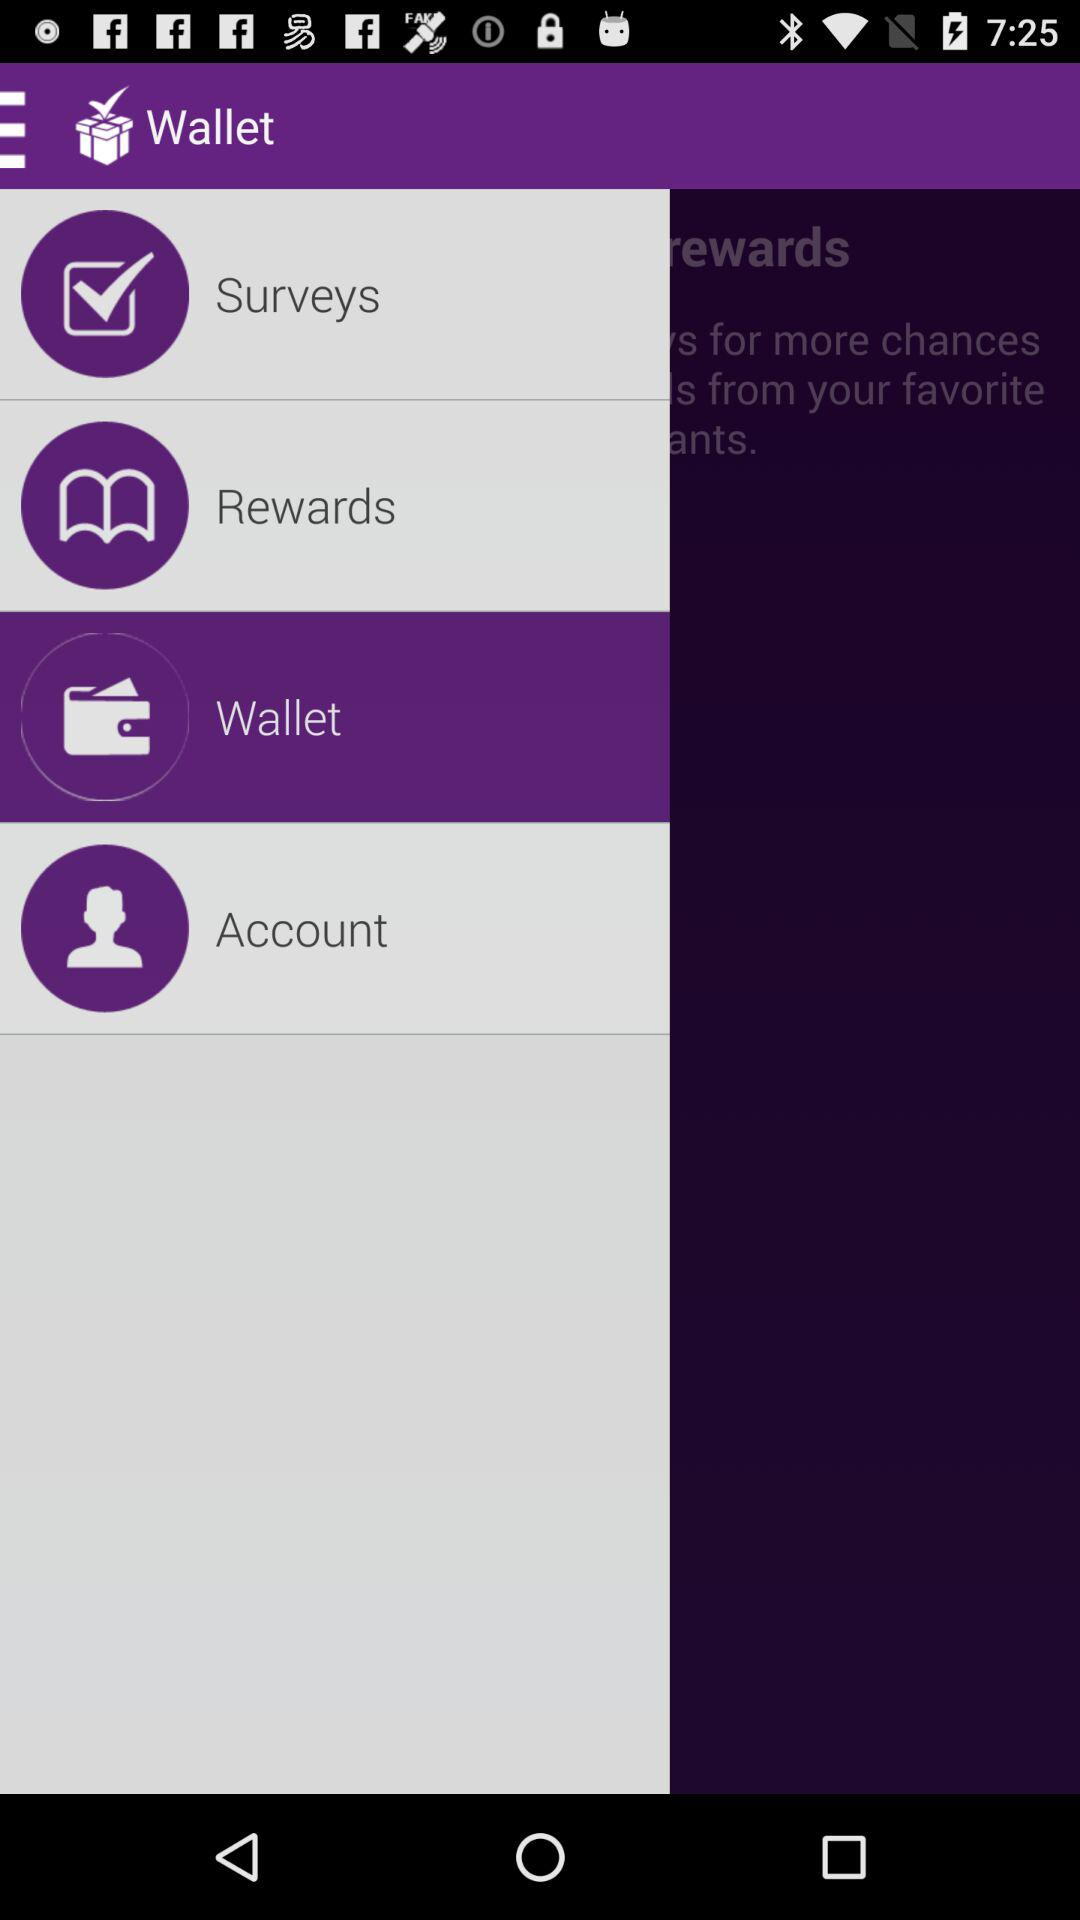Which item is selected? The selected item is "Wallet". 